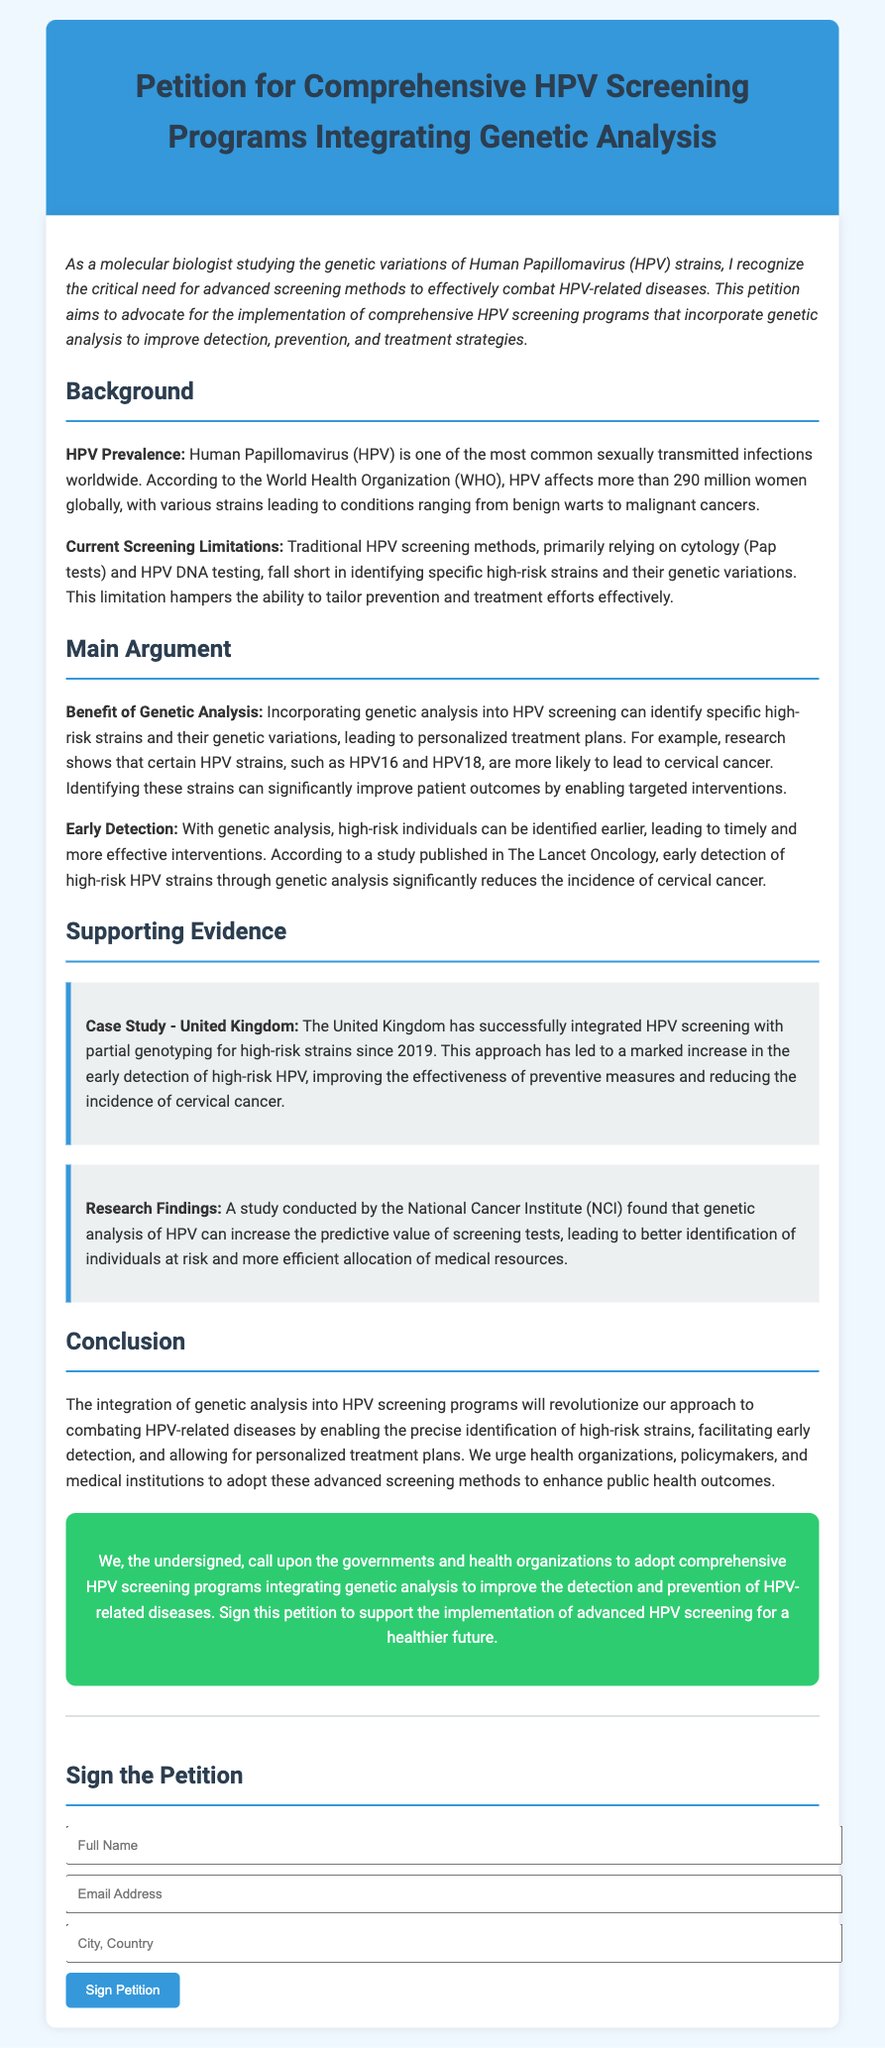What is the title of the petition? The title of the petition is stated prominently at the top of the document, emphasizing the main focus of the initiative.
Answer: Petition for Comprehensive HPV Screening Programs Integrating Genetic Analysis How many women are affected by HPV globally? The document mentions a statistic provided by the World Health Organization, which highlights the vast number of women impacted by this infection.
Answer: More than 290 million What are the current limitations of HPV screening methods? The document outlines the shortcomings of traditional methods such as cytology and HPV DNA testing, specifying what they fail to do.
Answer: Identifying specific high-risk strains and their genetic variations Which specific HPV strains are mentioned as being more likely to lead to cervical cancer? The main argument of the petition refers to notable strains that have a higher correlation with cancer risk.
Answer: HPV16 and HPV18 What has the UK integrated since 2019 regarding HPV screening? The document cites a case study that illustrates a successful integration in screening practices within a specific region.
Answer: HPV screening with partial genotyping for high-risk strains What is the main call to action in the petition? The conclusion section summarizes the primary request directed at health organizations and policymakers, encouraging them to take specific actions.
Answer: Adopt comprehensive HPV screening programs integrating genetic analysis Which institute conducted a study on genetic analysis of HPV? The supporting evidence includes a reference to a specific organization known for its research in cancer-related studies.
Answer: National Cancer Institute What is the background regarding HPV prevalence? The background section addresses critical information related to the infection's commonality and its impact on women.
Answer: One of the most common sexually transmitted infections worldwide 